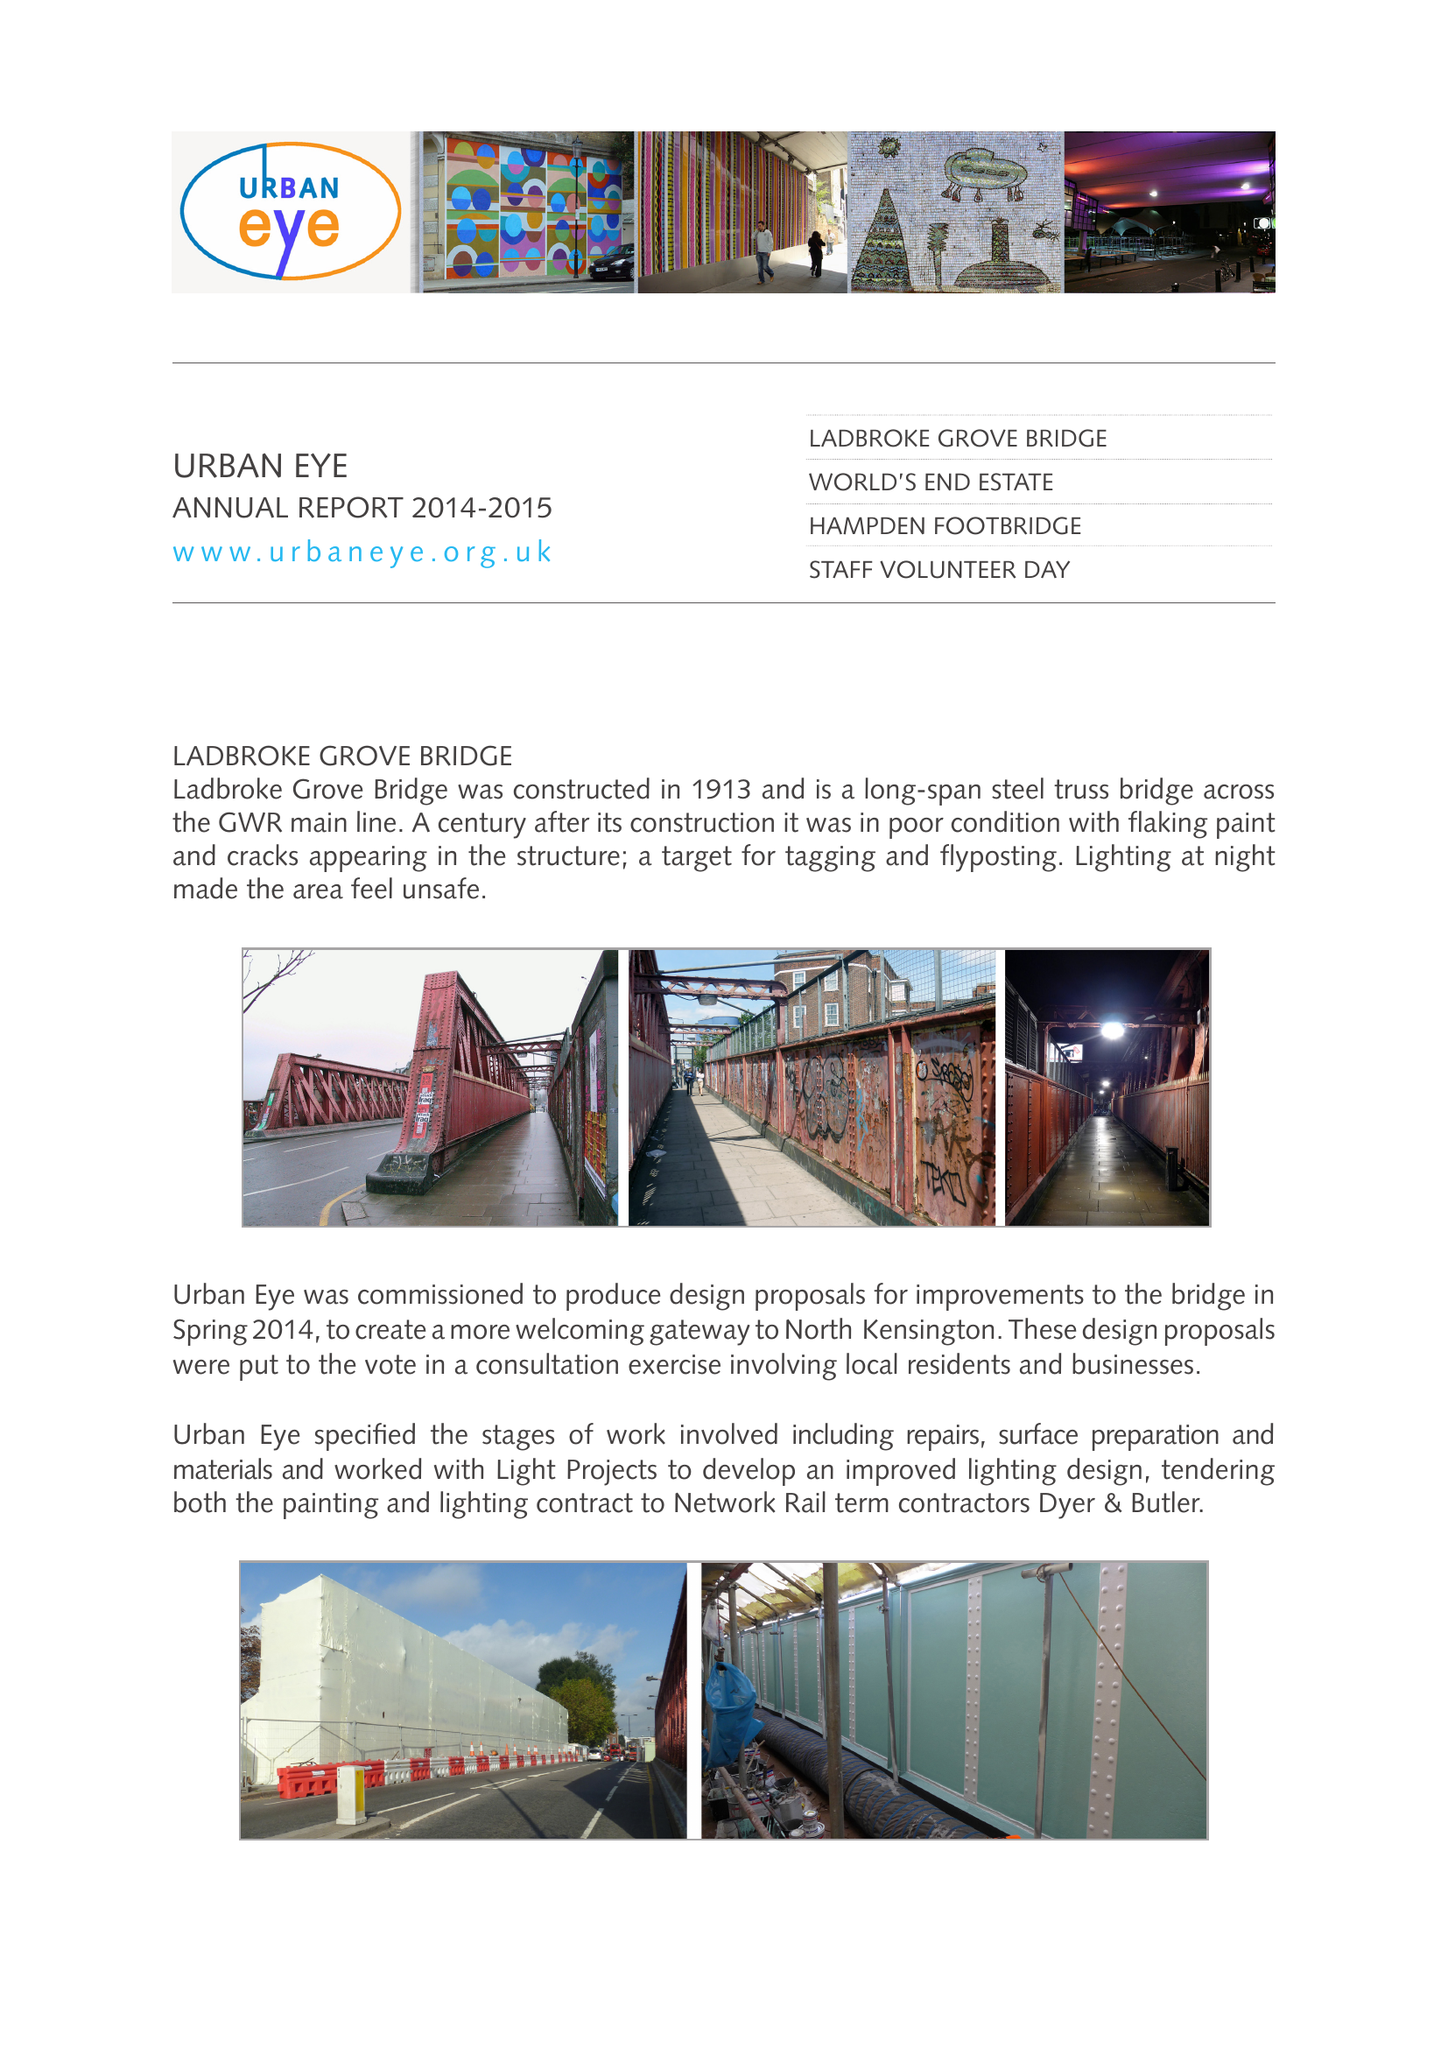What is the value for the income_annually_in_british_pounds?
Answer the question using a single word or phrase. 48176.00 